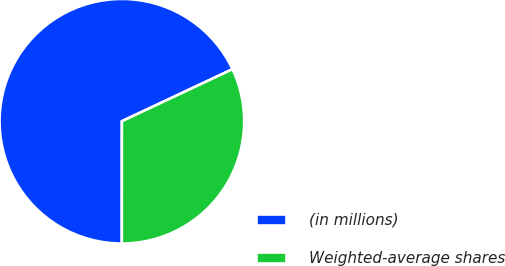Convert chart. <chart><loc_0><loc_0><loc_500><loc_500><pie_chart><fcel>(in millions)<fcel>Weighted-average shares<nl><fcel>68.0%<fcel>32.0%<nl></chart> 